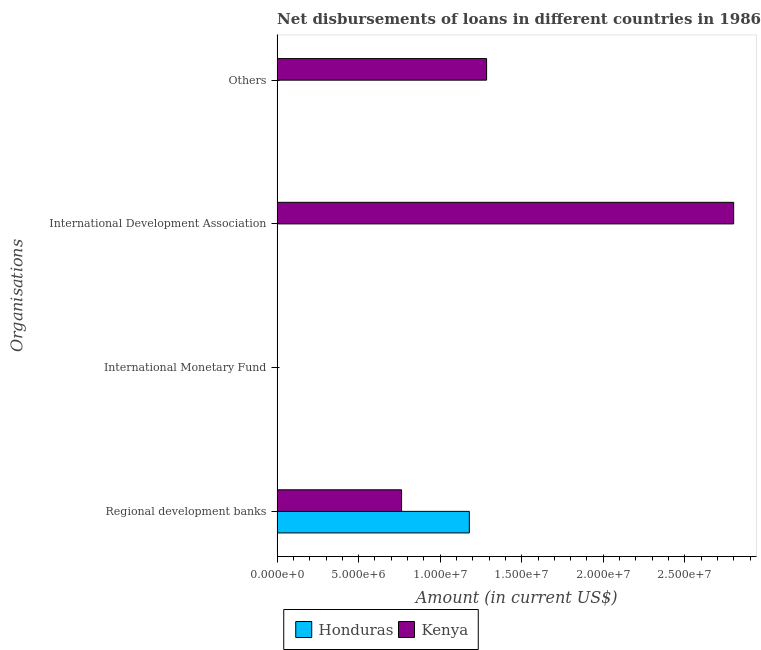What is the label of the 1st group of bars from the top?
Your response must be concise. Others. What is the amount of loan disimbursed by international development association in Honduras?
Offer a very short reply. 0. Across all countries, what is the maximum amount of loan disimbursed by international development association?
Keep it short and to the point. 2.80e+07. In which country was the amount of loan disimbursed by other organisations maximum?
Keep it short and to the point. Kenya. What is the total amount of loan disimbursed by regional development banks in the graph?
Provide a succinct answer. 1.94e+07. What is the difference between the amount of loan disimbursed by regional development banks in Kenya and that in Honduras?
Provide a succinct answer. -4.15e+06. What is the difference between the amount of loan disimbursed by international development association in Kenya and the amount of loan disimbursed by other organisations in Honduras?
Ensure brevity in your answer.  2.80e+07. What is the average amount of loan disimbursed by international development association per country?
Ensure brevity in your answer.  1.40e+07. What is the difference between the amount of loan disimbursed by other organisations and amount of loan disimbursed by regional development banks in Kenya?
Ensure brevity in your answer.  5.21e+06. What is the ratio of the amount of loan disimbursed by regional development banks in Honduras to that in Kenya?
Your answer should be compact. 1.54. What is the difference between the highest and the second highest amount of loan disimbursed by regional development banks?
Offer a very short reply. 4.15e+06. What is the difference between the highest and the lowest amount of loan disimbursed by regional development banks?
Your answer should be compact. 4.15e+06. In how many countries, is the amount of loan disimbursed by other organisations greater than the average amount of loan disimbursed by other organisations taken over all countries?
Offer a terse response. 1. Is it the case that in every country, the sum of the amount of loan disimbursed by other organisations and amount of loan disimbursed by regional development banks is greater than the sum of amount of loan disimbursed by international monetary fund and amount of loan disimbursed by international development association?
Make the answer very short. No. Is it the case that in every country, the sum of the amount of loan disimbursed by regional development banks and amount of loan disimbursed by international monetary fund is greater than the amount of loan disimbursed by international development association?
Keep it short and to the point. No. How many bars are there?
Keep it short and to the point. 4. Does the graph contain any zero values?
Your response must be concise. Yes. Where does the legend appear in the graph?
Offer a terse response. Bottom center. How are the legend labels stacked?
Your answer should be very brief. Horizontal. What is the title of the graph?
Make the answer very short. Net disbursements of loans in different countries in 1986. Does "Sint Maarten (Dutch part)" appear as one of the legend labels in the graph?
Keep it short and to the point. No. What is the label or title of the Y-axis?
Ensure brevity in your answer.  Organisations. What is the Amount (in current US$) of Honduras in Regional development banks?
Give a very brief answer. 1.18e+07. What is the Amount (in current US$) in Kenya in Regional development banks?
Give a very brief answer. 7.63e+06. What is the Amount (in current US$) in Kenya in International Monetary Fund?
Provide a short and direct response. 0. What is the Amount (in current US$) of Kenya in International Development Association?
Keep it short and to the point. 2.80e+07. What is the Amount (in current US$) in Honduras in Others?
Your answer should be very brief. 0. What is the Amount (in current US$) in Kenya in Others?
Make the answer very short. 1.28e+07. Across all Organisations, what is the maximum Amount (in current US$) of Honduras?
Make the answer very short. 1.18e+07. Across all Organisations, what is the maximum Amount (in current US$) of Kenya?
Keep it short and to the point. 2.80e+07. Across all Organisations, what is the minimum Amount (in current US$) of Kenya?
Keep it short and to the point. 0. What is the total Amount (in current US$) in Honduras in the graph?
Keep it short and to the point. 1.18e+07. What is the total Amount (in current US$) of Kenya in the graph?
Make the answer very short. 4.85e+07. What is the difference between the Amount (in current US$) of Kenya in Regional development banks and that in International Development Association?
Make the answer very short. -2.04e+07. What is the difference between the Amount (in current US$) in Kenya in Regional development banks and that in Others?
Your response must be concise. -5.21e+06. What is the difference between the Amount (in current US$) of Kenya in International Development Association and that in Others?
Keep it short and to the point. 1.52e+07. What is the difference between the Amount (in current US$) of Honduras in Regional development banks and the Amount (in current US$) of Kenya in International Development Association?
Give a very brief answer. -1.62e+07. What is the difference between the Amount (in current US$) of Honduras in Regional development banks and the Amount (in current US$) of Kenya in Others?
Provide a succinct answer. -1.06e+06. What is the average Amount (in current US$) in Honduras per Organisations?
Give a very brief answer. 2.95e+06. What is the average Amount (in current US$) in Kenya per Organisations?
Provide a short and direct response. 1.21e+07. What is the difference between the Amount (in current US$) of Honduras and Amount (in current US$) of Kenya in Regional development banks?
Give a very brief answer. 4.15e+06. What is the ratio of the Amount (in current US$) in Kenya in Regional development banks to that in International Development Association?
Ensure brevity in your answer.  0.27. What is the ratio of the Amount (in current US$) in Kenya in Regional development banks to that in Others?
Offer a terse response. 0.59. What is the ratio of the Amount (in current US$) of Kenya in International Development Association to that in Others?
Your response must be concise. 2.18. What is the difference between the highest and the second highest Amount (in current US$) of Kenya?
Make the answer very short. 1.52e+07. What is the difference between the highest and the lowest Amount (in current US$) in Honduras?
Make the answer very short. 1.18e+07. What is the difference between the highest and the lowest Amount (in current US$) of Kenya?
Your answer should be very brief. 2.80e+07. 